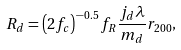<formula> <loc_0><loc_0><loc_500><loc_500>R _ { d } = \left ( 2 f _ { c } \right ) ^ { - 0 . 5 } f _ { R } \frac { j _ { d } \lambda } { m _ { d } } r _ { 2 0 0 } ,</formula> 